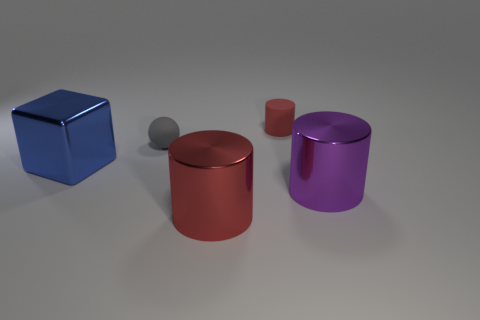Add 3 tiny brown matte objects. How many objects exist? 8 Subtract all cylinders. How many objects are left? 2 Subtract 0 cyan blocks. How many objects are left? 5 Subtract all large cyan objects. Subtract all red metal cylinders. How many objects are left? 4 Add 4 large red shiny cylinders. How many large red shiny cylinders are left? 5 Add 5 red rubber blocks. How many red rubber blocks exist? 5 